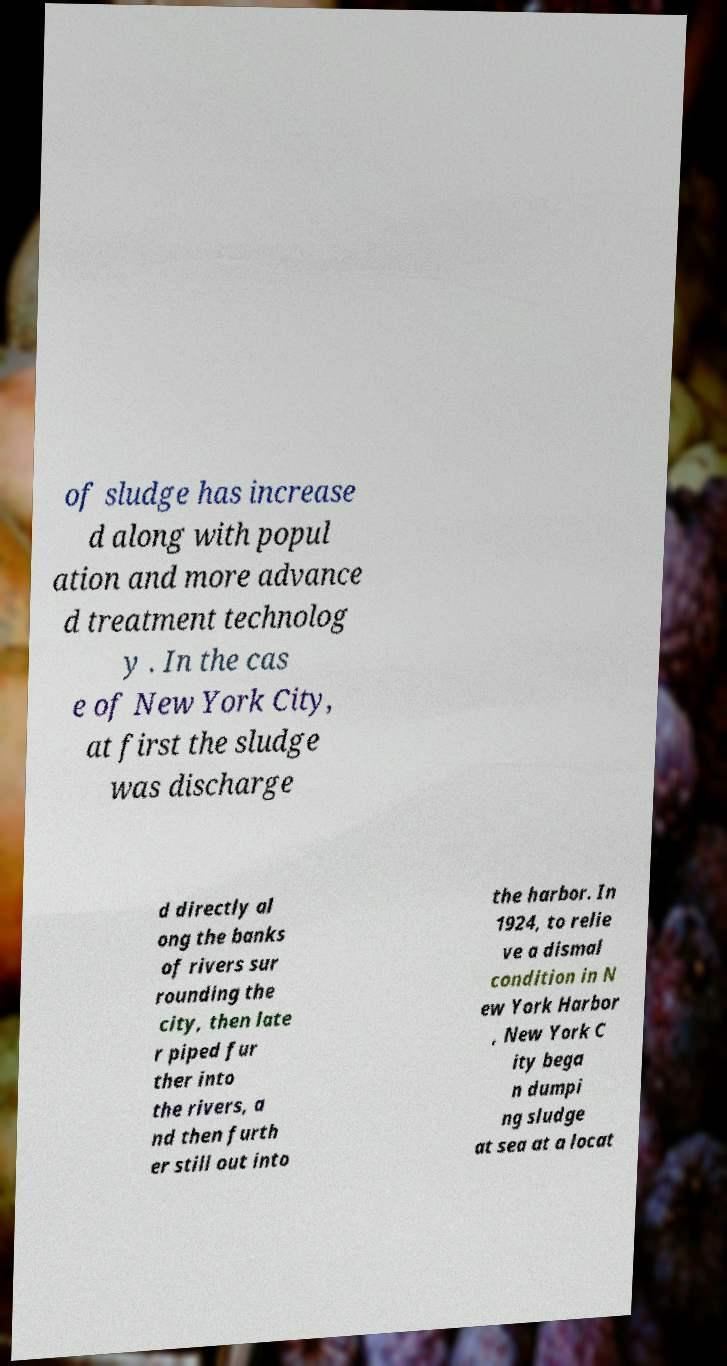There's text embedded in this image that I need extracted. Can you transcribe it verbatim? of sludge has increase d along with popul ation and more advance d treatment technolog y . In the cas e of New York City, at first the sludge was discharge d directly al ong the banks of rivers sur rounding the city, then late r piped fur ther into the rivers, a nd then furth er still out into the harbor. In 1924, to relie ve a dismal condition in N ew York Harbor , New York C ity bega n dumpi ng sludge at sea at a locat 